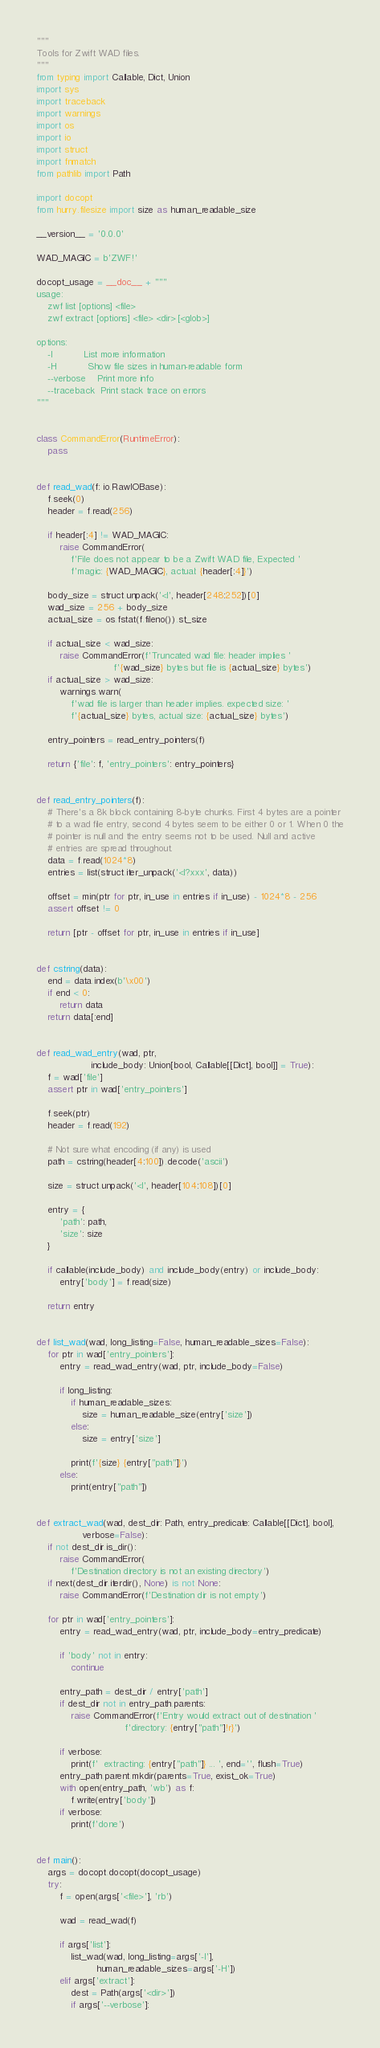Convert code to text. <code><loc_0><loc_0><loc_500><loc_500><_Python_>"""
Tools for Zwift WAD files.
"""
from typing import Callable, Dict, Union
import sys
import traceback
import warnings
import os
import io
import struct
import fnmatch
from pathlib import Path

import docopt
from hurry.filesize import size as human_readable_size

__version__ = '0.0.0'

WAD_MAGIC = b'ZWF!'

docopt_usage = __doc__ + """
usage: 
    zwf list [options] <file>
    zwf extract [options] <file> <dir> [<glob>]

options:
    -l           List more information
    -H           Show file sizes in human-readable form
    --verbose    Print more info
    --traceback  Print stack trace on errors
"""


class CommandError(RuntimeError):
    pass


def read_wad(f: io.RawIOBase):
    f.seek(0)
    header = f.read(256)

    if header[:4] != WAD_MAGIC:
        raise CommandError(
            f'File does not appear to be a Zwift WAD file, Expected '
            f'magic: {WAD_MAGIC}, actual: {header[:4]}')

    body_size = struct.unpack('<I', header[248:252])[0]
    wad_size = 256 + body_size
    actual_size = os.fstat(f.fileno()).st_size

    if actual_size < wad_size:
        raise CommandError(f'Truncated wad file: header implies '
                           f'{wad_size} bytes but file is {actual_size} bytes')
    if actual_size > wad_size:
        warnings.warn(
            f'wad file is larger than header implies. expected size: '
            f'{actual_size} bytes, actual size: {actual_size} bytes')

    entry_pointers = read_entry_pointers(f)

    return {'file': f, 'entry_pointers': entry_pointers}


def read_entry_pointers(f):
    # There's a 8k block containing 8-byte chunks. First 4 bytes are a pointer
    # to a wad file entry, second 4 bytes seem to be either 0 or 1. When 0 the
    # pointer is null and the entry seems not to be used. Null and active
    # entries are spread throughout.
    data = f.read(1024*8)
    entries = list(struct.iter_unpack('<I?xxx', data))

    offset = min(ptr for ptr, in_use in entries if in_use) - 1024*8 - 256
    assert offset != 0

    return [ptr - offset for ptr, in_use in entries if in_use]


def cstring(data):
    end = data.index(b'\x00')
    if end < 0:
        return data
    return data[:end]


def read_wad_entry(wad, ptr,
                   include_body: Union[bool, Callable[[Dict], bool]] = True):
    f = wad['file']
    assert ptr in wad['entry_pointers']

    f.seek(ptr)
    header = f.read(192)

    # Not sure what encoding (if any) is used
    path = cstring(header[4:100]).decode('ascii')

    size = struct.unpack('<I', header[104:108])[0]

    entry = {
        'path': path,
        'size': size
    }

    if callable(include_body) and include_body(entry) or include_body:
        entry['body'] = f.read(size)

    return entry


def list_wad(wad, long_listing=False, human_readable_sizes=False):
    for ptr in wad['entry_pointers']:
        entry = read_wad_entry(wad, ptr, include_body=False)

        if long_listing:
            if human_readable_sizes:
                size = human_readable_size(entry['size'])
            else:
                size = entry['size']

            print(f'{size} {entry["path"]}')
        else:
            print(entry["path"])


def extract_wad(wad, dest_dir: Path, entry_predicate: Callable[[Dict], bool],
                verbose=False):
    if not dest_dir.is_dir():
        raise CommandError(
            f'Destination directory is not an existing directory')
    if next(dest_dir.iterdir(), None) is not None:
        raise CommandError(f'Destination dir is not empty')

    for ptr in wad['entry_pointers']:
        entry = read_wad_entry(wad, ptr, include_body=entry_predicate)

        if 'body' not in entry:
            continue

        entry_path = dest_dir / entry['path']
        if dest_dir not in entry_path.parents:
            raise CommandError(f'Entry would extract out of destination '
                               f'directory: {entry["path"]!r}')

        if verbose:
            print(f'  extracting: {entry["path"]} ... ', end='', flush=True)
        entry_path.parent.mkdir(parents=True, exist_ok=True)
        with open(entry_path, 'wb') as f:
            f.write(entry['body'])
        if verbose:
            print(f'done')


def main():
    args = docopt.docopt(docopt_usage)
    try:
        f = open(args['<file>'], 'rb')

        wad = read_wad(f)

        if args['list']:
            list_wad(wad, long_listing=args['-l'],
                     human_readable_sizes=args['-H'])
        elif args['extract']:
            dest = Path(args['<dir>'])
            if args['--verbose']:</code> 